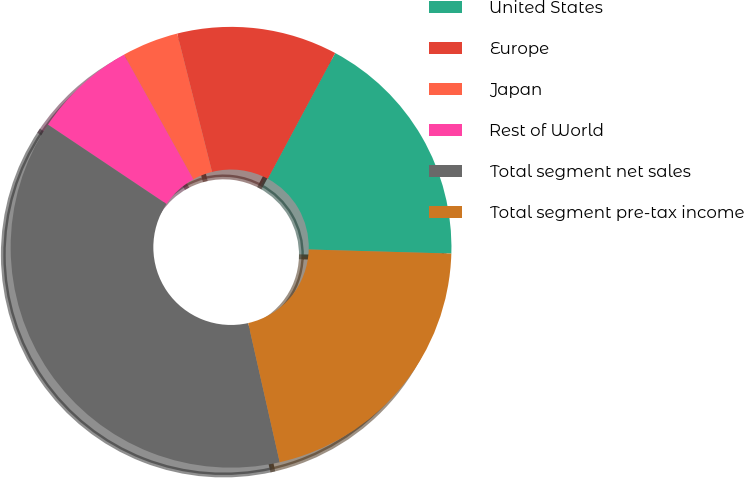<chart> <loc_0><loc_0><loc_500><loc_500><pie_chart><fcel>United States<fcel>Europe<fcel>Japan<fcel>Rest of World<fcel>Total segment net sales<fcel>Total segment pre-tax income<nl><fcel>17.62%<fcel>11.76%<fcel>4.15%<fcel>7.53%<fcel>37.93%<fcel>21.0%<nl></chart> 